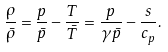<formula> <loc_0><loc_0><loc_500><loc_500>\frac { \rho } { \bar { \rho } } = \frac { p } { \bar { p } } - \frac { T } { \bar { T } } = \frac { p } { \gamma \bar { p } } - \frac { s } { c _ { p } } .</formula> 